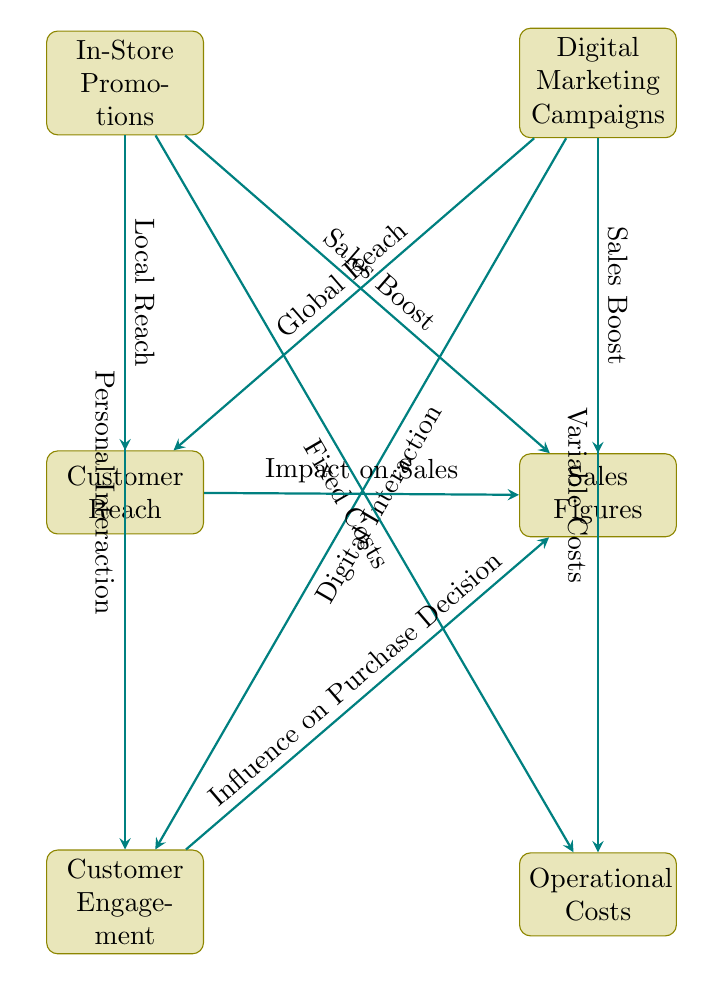What are the two main methods compared in the diagram? The diagram highlights "In-Store Promotions" and "Digital Marketing Campaigns" as the two primary methods being analyzed for their sales effectiveness.
Answer: In-Store Promotions, Digital Marketing Campaigns Which method offers "Local Reach"? The diagram clearly links "In-Store Promotions" to "Local Reach," indicating this method's focus on reaching customers in the vicinity of the store.
Answer: In-Store Promotions What is the relationship between "Customer Engagement" and "Sales Figures"? The diagram indicates that "Customer Engagement" influences "Sales Figures," as shown by the arrow connecting these two nodes labeled "Influence on Purchase Decision."
Answer: Influence on Purchase Decision How many nodes are present in this diagram? Counting all the distinct labeled items in the diagram, there are a total of six nodes, including both promotional methods and their corresponding impacts.
Answer: Six What type of costs are associated with "Digital Marketing Campaigns"? According to the diagram, "Digital Marketing Campaigns" are linked to "Variable Costs," indicating the costs may fluctuate based on the campaign's performance and reach.
Answer: Variable Costs Which method provides "Personal Interaction"? The diagram illustrates that "In-Store Promotions" facilitate "Personal Interaction" with customers, distinguishing it from digital methods.
Answer: In-Store Promotions What type of reach does "Digital Marketing Campaigns" achieve? The diagram specifies that "Digital Marketing Campaigns" are associated with "Global Reach," indicating their ability to connect with a wider audience beyond local customers.
Answer: Global Reach What effect do both promotional methods have on sales? The diagram shows that both "In-Store Promotions" and "Digital Marketing Campaigns" contribute to a "Sales Boost," indicating their effectiveness in increasing sales figures.
Answer: Sales Boost 